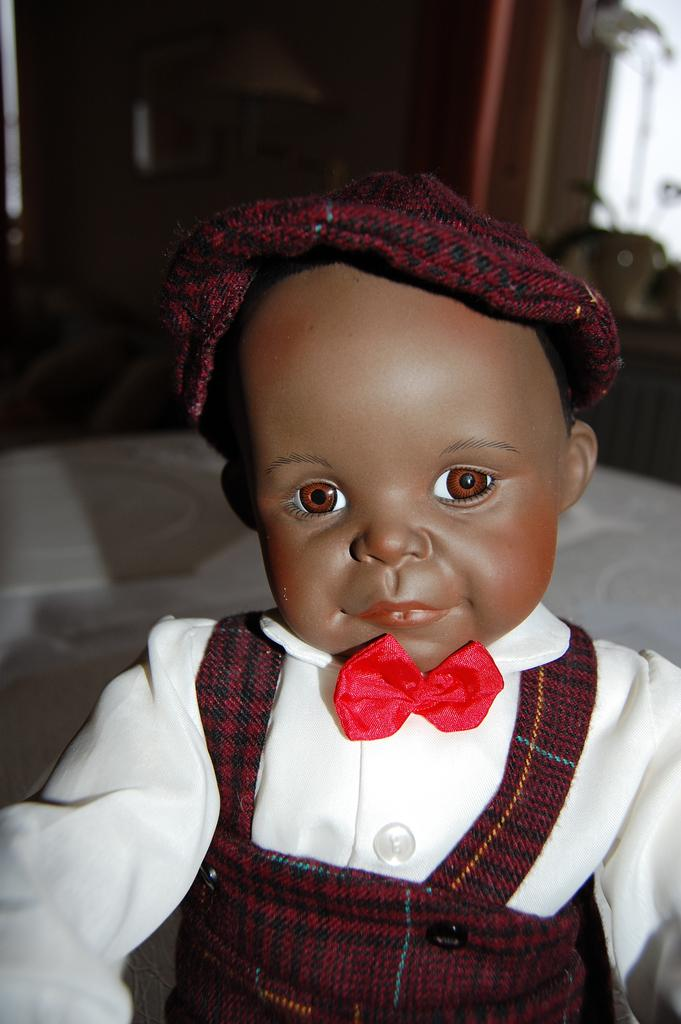What is the main subject of the image? There is a toy in the image. Can you describe the toy's appearance? The toy is wearing a dress with white, red, black, and brown colors, and it has a red bow. What can be seen in the background of the image? There are objects in the background of the image. What flavor of pancake is the toy holding in the image? There is no pancake present in the image, so it cannot be determined if the toy is holding one or what flavor it might be. 